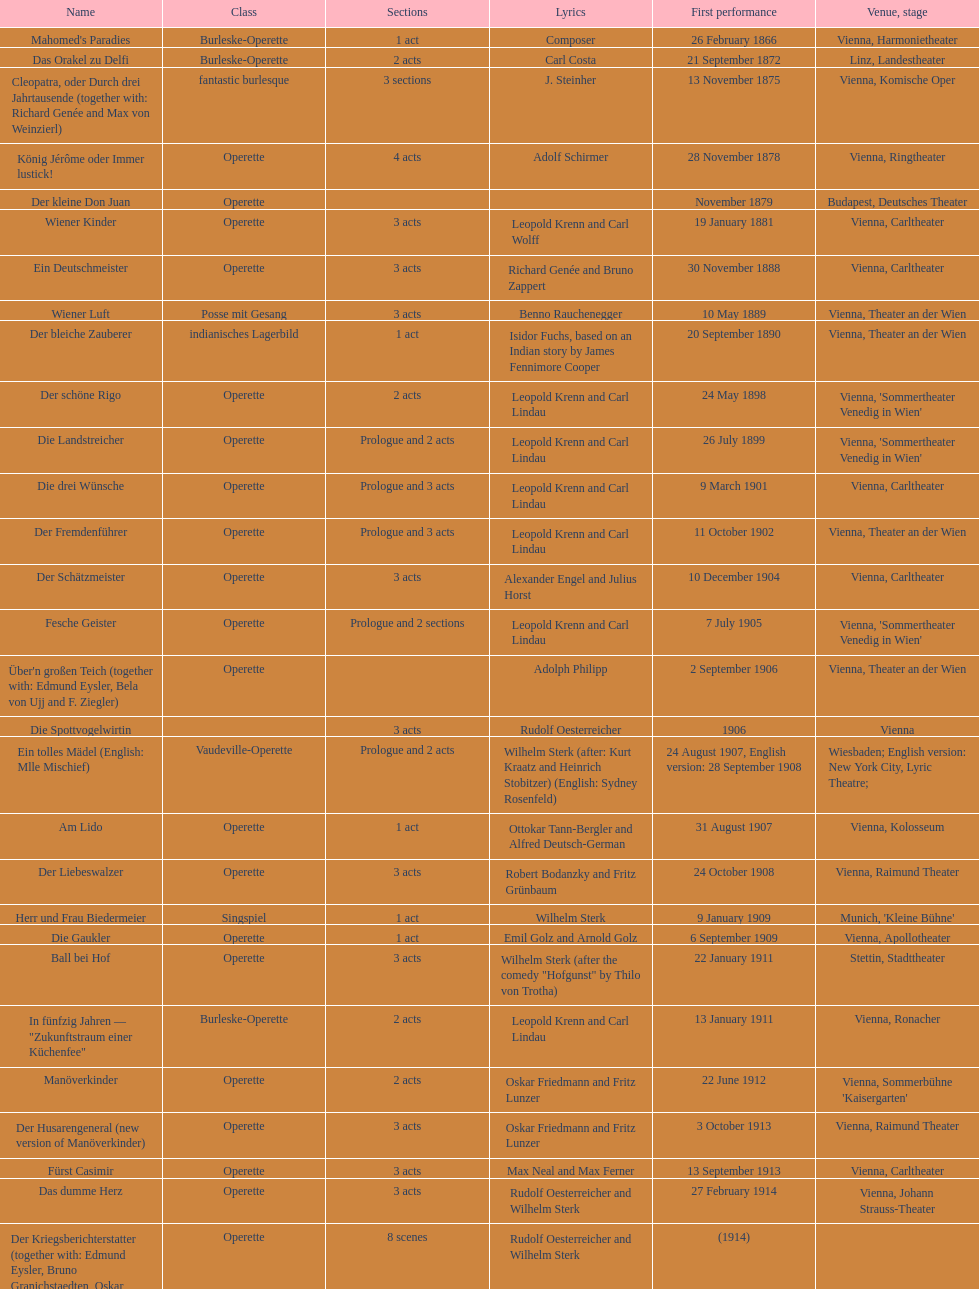Can you give me this table as a dict? {'header': ['Name', 'Class', 'Sections', 'Lyrics', 'First performance', 'Venue, stage'], 'rows': [["Mahomed's Paradies", 'Burleske-Operette', '1 act', 'Composer', '26 February 1866', 'Vienna, Harmonietheater'], ['Das Orakel zu Delfi', 'Burleske-Operette', '2 acts', 'Carl Costa', '21 September 1872', 'Linz, Landestheater'], ['Cleopatra, oder Durch drei Jahrtausende (together with: Richard Genée and Max von Weinzierl)', 'fantastic burlesque', '3 sections', 'J. Steinher', '13 November 1875', 'Vienna, Komische Oper'], ['König Jérôme oder Immer lustick!', 'Operette', '4 acts', 'Adolf Schirmer', '28 November 1878', 'Vienna, Ringtheater'], ['Der kleine Don Juan', 'Operette', '', '', 'November 1879', 'Budapest, Deutsches Theater'], ['Wiener Kinder', 'Operette', '3 acts', 'Leopold Krenn and Carl Wolff', '19 January 1881', 'Vienna, Carltheater'], ['Ein Deutschmeister', 'Operette', '3 acts', 'Richard Genée and Bruno Zappert', '30 November 1888', 'Vienna, Carltheater'], ['Wiener Luft', 'Posse mit Gesang', '3 acts', 'Benno Rauchenegger', '10 May 1889', 'Vienna, Theater an der Wien'], ['Der bleiche Zauberer', 'indianisches Lagerbild', '1 act', 'Isidor Fuchs, based on an Indian story by James Fennimore Cooper', '20 September 1890', 'Vienna, Theater an der Wien'], ['Der schöne Rigo', 'Operette', '2 acts', 'Leopold Krenn and Carl Lindau', '24 May 1898', "Vienna, 'Sommertheater Venedig in Wien'"], ['Die Landstreicher', 'Operette', 'Prologue and 2 acts', 'Leopold Krenn and Carl Lindau', '26 July 1899', "Vienna, 'Sommertheater Venedig in Wien'"], ['Die drei Wünsche', 'Operette', 'Prologue and 3 acts', 'Leopold Krenn and Carl Lindau', '9 March 1901', 'Vienna, Carltheater'], ['Der Fremdenführer', 'Operette', 'Prologue and 3 acts', 'Leopold Krenn and Carl Lindau', '11 October 1902', 'Vienna, Theater an der Wien'], ['Der Schätzmeister', 'Operette', '3 acts', 'Alexander Engel and Julius Horst', '10 December 1904', 'Vienna, Carltheater'], ['Fesche Geister', 'Operette', 'Prologue and 2 sections', 'Leopold Krenn and Carl Lindau', '7 July 1905', "Vienna, 'Sommertheater Venedig in Wien'"], ["Über'n großen Teich (together with: Edmund Eysler, Bela von Ujj and F. Ziegler)", 'Operette', '', 'Adolph Philipp', '2 September 1906', 'Vienna, Theater an der Wien'], ['Die Spottvogelwirtin', '', '3 acts', 'Rudolf Oesterreicher', '1906', 'Vienna'], ['Ein tolles Mädel (English: Mlle Mischief)', 'Vaudeville-Operette', 'Prologue and 2 acts', 'Wilhelm Sterk (after: Kurt Kraatz and Heinrich Stobitzer) (English: Sydney Rosenfeld)', '24 August 1907, English version: 28 September 1908', 'Wiesbaden; English version: New York City, Lyric Theatre;'], ['Am Lido', 'Operette', '1 act', 'Ottokar Tann-Bergler and Alfred Deutsch-German', '31 August 1907', 'Vienna, Kolosseum'], ['Der Liebeswalzer', 'Operette', '3 acts', 'Robert Bodanzky and Fritz Grünbaum', '24 October 1908', 'Vienna, Raimund Theater'], ['Herr und Frau Biedermeier', 'Singspiel', '1 act', 'Wilhelm Sterk', '9 January 1909', "Munich, 'Kleine Bühne'"], ['Die Gaukler', 'Operette', '1 act', 'Emil Golz and Arnold Golz', '6 September 1909', 'Vienna, Apollotheater'], ['Ball bei Hof', 'Operette', '3 acts', 'Wilhelm Sterk (after the comedy "Hofgunst" by Thilo von Trotha)', '22 January 1911', 'Stettin, Stadttheater'], ['In fünfzig Jahren — "Zukunftstraum einer Küchenfee"', 'Burleske-Operette', '2 acts', 'Leopold Krenn and Carl Lindau', '13 January 1911', 'Vienna, Ronacher'], ['Manöverkinder', 'Operette', '2 acts', 'Oskar Friedmann and Fritz Lunzer', '22 June 1912', "Vienna, Sommerbühne 'Kaisergarten'"], ['Der Husarengeneral (new version of Manöverkinder)', 'Operette', '3 acts', 'Oskar Friedmann and Fritz Lunzer', '3 October 1913', 'Vienna, Raimund Theater'], ['Fürst Casimir', 'Operette', '3 acts', 'Max Neal and Max Ferner', '13 September 1913', 'Vienna, Carltheater'], ['Das dumme Herz', 'Operette', '3 acts', 'Rudolf Oesterreicher and Wilhelm Sterk', '27 February 1914', 'Vienna, Johann Strauss-Theater'], ['Der Kriegsberichterstatter (together with: Edmund Eysler, Bruno Granichstaedten, Oskar Nedbal, Charles Weinberger)', 'Operette', '8 scenes', 'Rudolf Oesterreicher and Wilhelm Sterk', '(1914)', ''], ['Im siebenten Himmel', 'Operette', '3 acts', 'Max Neal and Max Ferner', '26 February 1916', 'Munich, Theater am Gärtnerplatz'], ['Deutschmeisterkapelle', 'Operette', '', 'Hubert Marischka and Rudolf Oesterreicher', '30 May 1958', 'Vienna, Raimund Theater'], ['Die verliebte Eskadron', 'Operette', '3 acts', 'Wilhelm Sterk (after B. Buchbinder)', '11 July 1930', 'Vienna, Johann-Strauß-Theater']]} All the dates are no later than what year? 1958. 